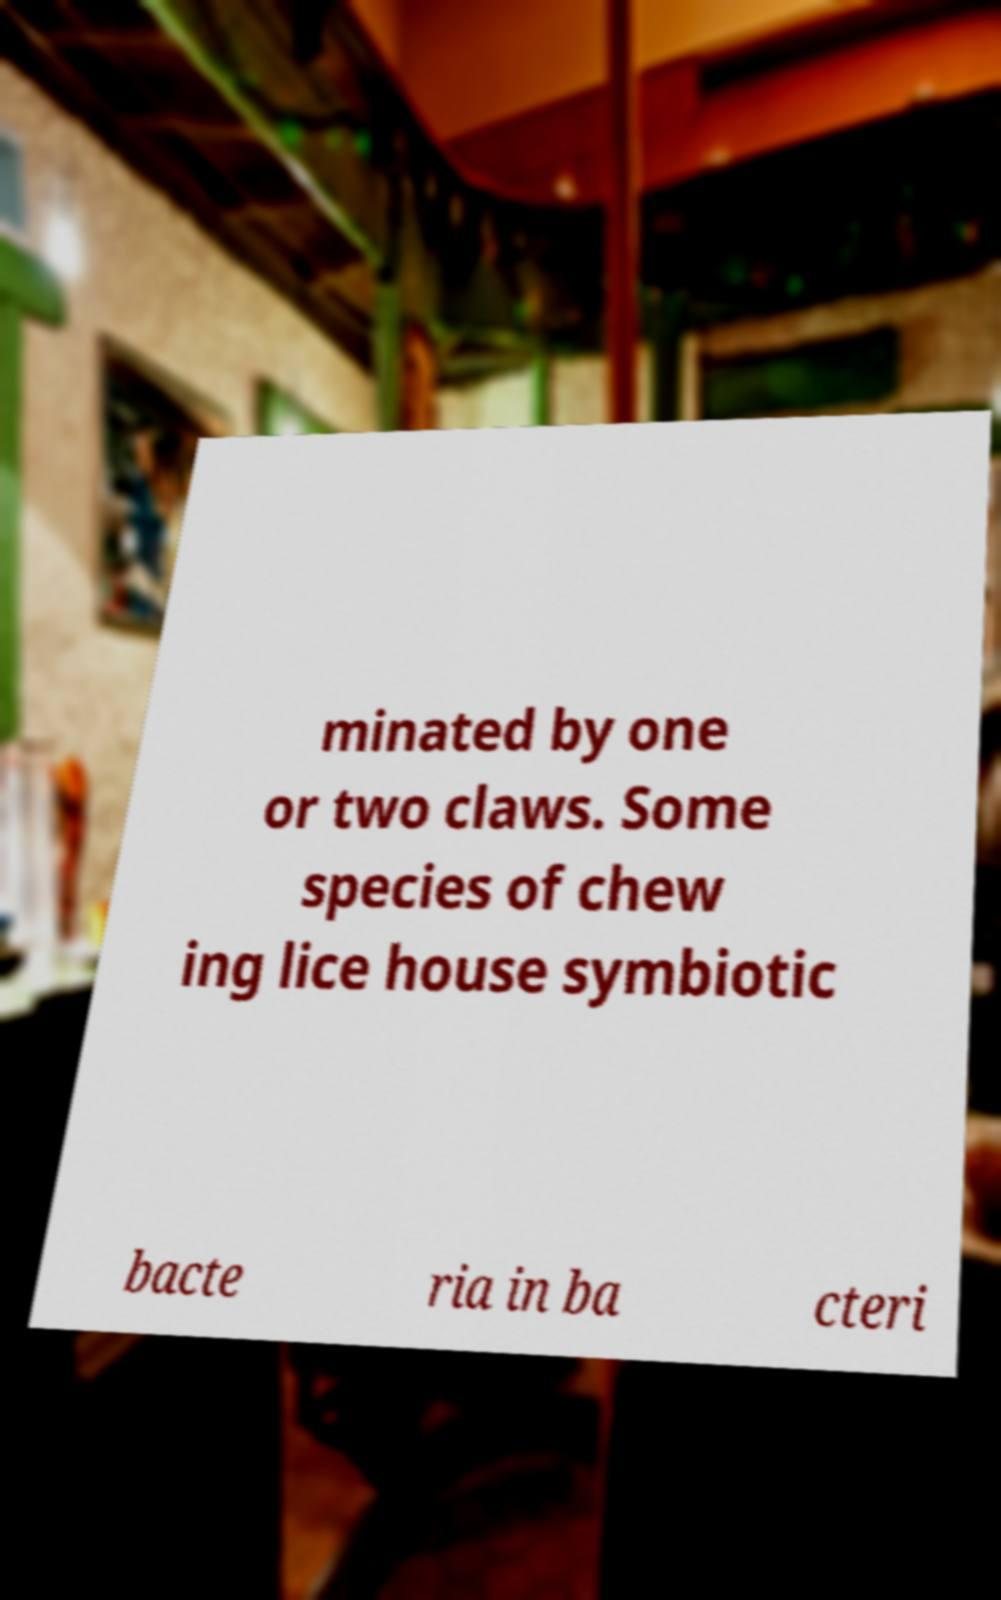Could you assist in decoding the text presented in this image and type it out clearly? minated by one or two claws. Some species of chew ing lice house symbiotic bacte ria in ba cteri 